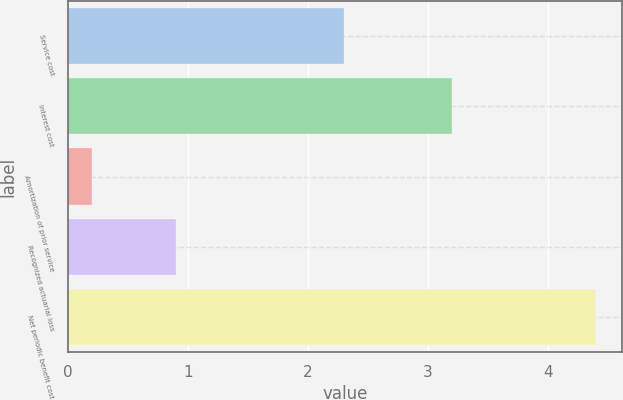<chart> <loc_0><loc_0><loc_500><loc_500><bar_chart><fcel>Service cost<fcel>Interest cost<fcel>Amortization of prior service<fcel>Recognized actuarial loss<fcel>Net periodic benefit cost<nl><fcel>2.3<fcel>3.2<fcel>0.2<fcel>0.9<fcel>4.4<nl></chart> 